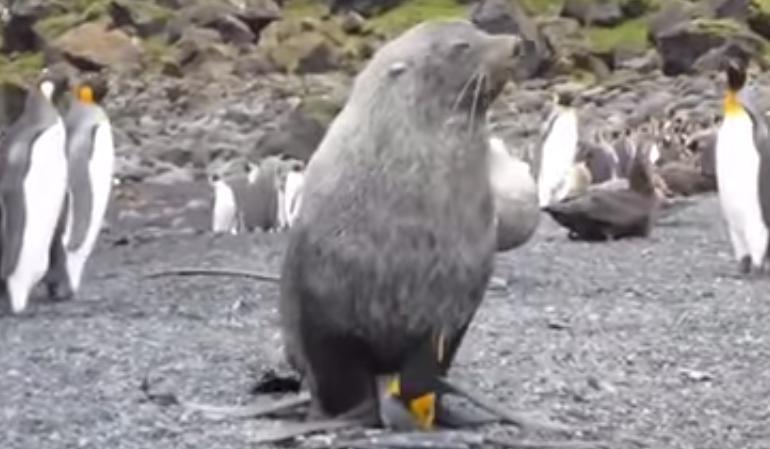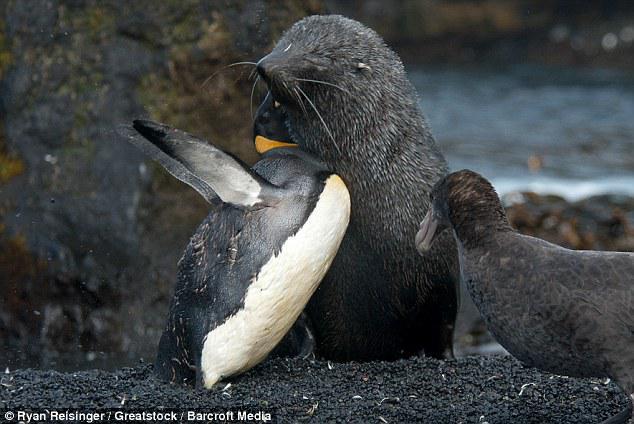The first image is the image on the left, the second image is the image on the right. Considering the images on both sides, is "a penguin has molting feathers" valid? Answer yes or no. No. The first image is the image on the left, the second image is the image on the right. Assess this claim about the two images: "There is exactly one seal.". Correct or not? Answer yes or no. No. 